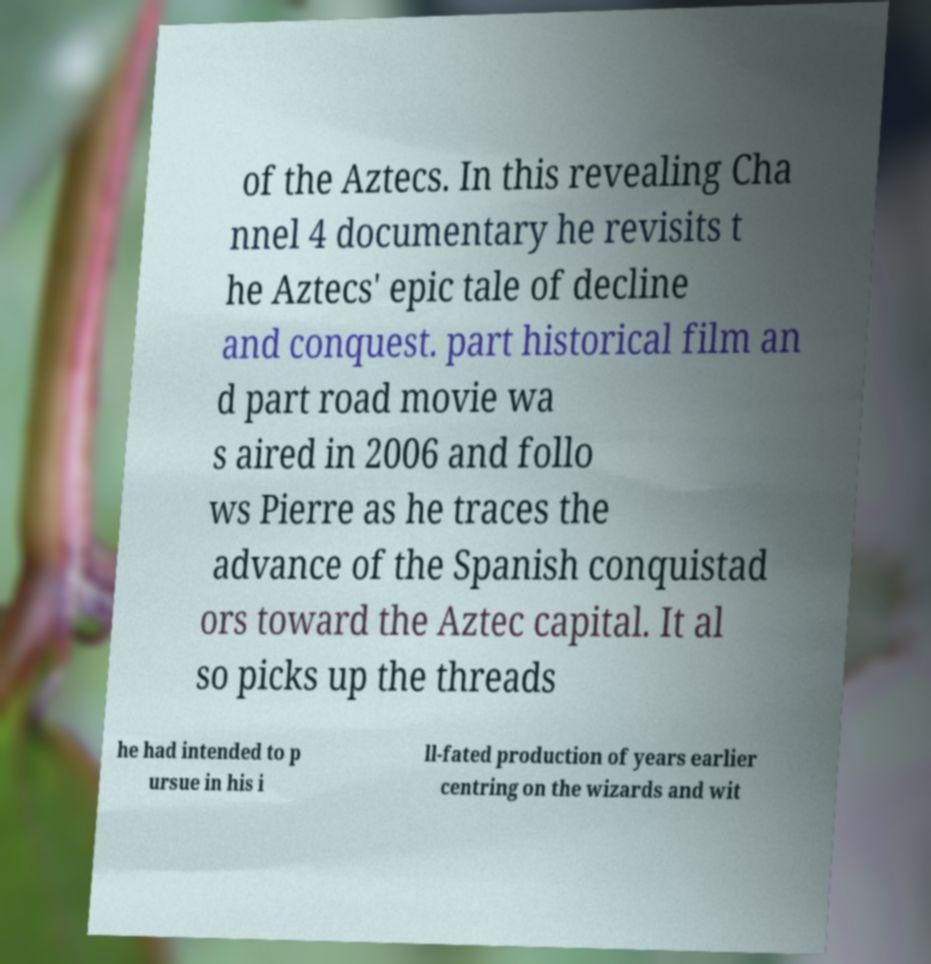Can you read and provide the text displayed in the image?This photo seems to have some interesting text. Can you extract and type it out for me? of the Aztecs. In this revealing Cha nnel 4 documentary he revisits t he Aztecs' epic tale of decline and conquest. part historical film an d part road movie wa s aired in 2006 and follo ws Pierre as he traces the advance of the Spanish conquistad ors toward the Aztec capital. It al so picks up the threads he had intended to p ursue in his i ll-fated production of years earlier centring on the wizards and wit 